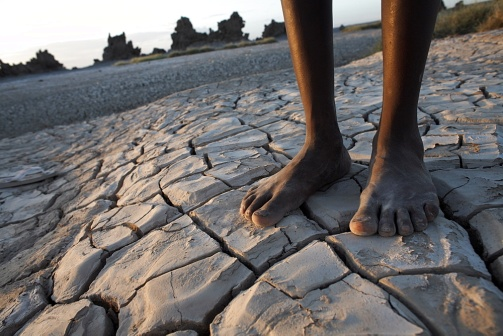What are the key elements in this picture? In the compelling photograph, we observe the notable distinction between the arid, parched earth with intricate patterns of deep cracks and a pair of human bare feet, dark in complexion, demonstrating an interaction between life and the desolate environment. The background features faint outlines of hardy vegetation clinging to life under the vast sky, which fades into the soft hues of twilight. Though the sun is not directly visible, its amber light suffuses the scene, signaling the close of day. This image beautifully captures the juxtaposition of endurance and hope amid challenging conditions. 